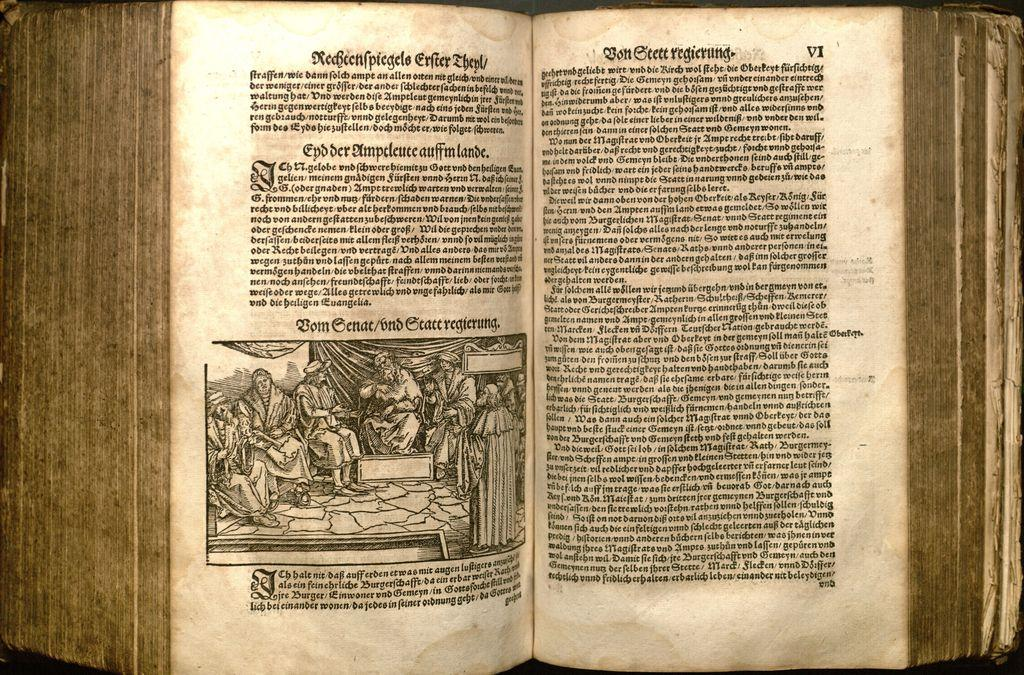<image>
Share a concise interpretation of the image provided. A book that looks old is open to a page marked VI. 